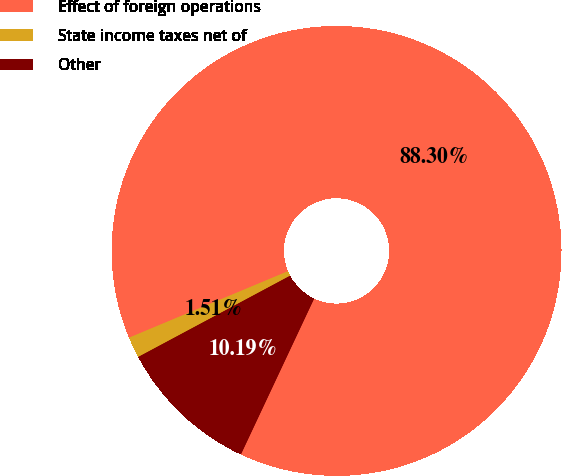Convert chart to OTSL. <chart><loc_0><loc_0><loc_500><loc_500><pie_chart><fcel>Effect of foreign operations<fcel>State income taxes net of<fcel>Other<nl><fcel>88.29%<fcel>1.51%<fcel>10.19%<nl></chart> 